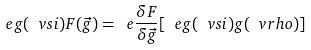Convert formula to latex. <formula><loc_0><loc_0><loc_500><loc_500>\ e g ( \ v s i ) F ( \vec { g } ) = \ e \frac { \delta F } { \delta \vec { g } } [ \ e g ( \ v s i ) g ( \ v r h o ) ]</formula> 